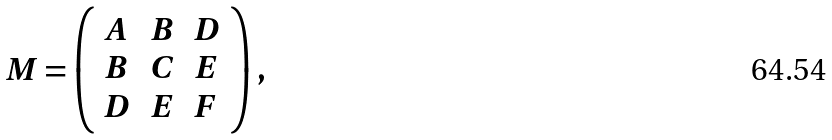<formula> <loc_0><loc_0><loc_500><loc_500>M = \left ( { \begin{array} { l l l } { A } & { B } & { D } \\ { B } & { C } & { E } \\ { D } & { E } & { F } \end{array} } \right ) ,</formula> 